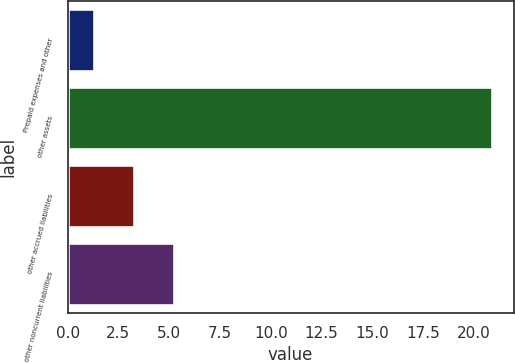Convert chart to OTSL. <chart><loc_0><loc_0><loc_500><loc_500><bar_chart><fcel>Prepaid expenses and other<fcel>other assets<fcel>other accrued liabilities<fcel>other noncurrent liabilities<nl><fcel>1.3<fcel>20.9<fcel>3.26<fcel>5.22<nl></chart> 